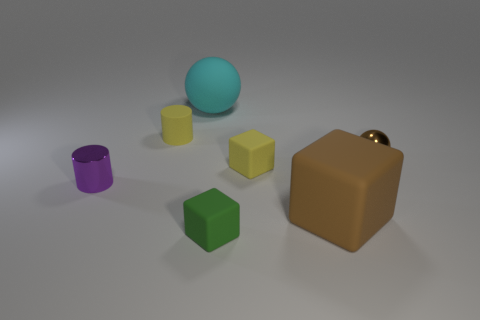There is a brown metal object; is it the same size as the yellow object on the left side of the big rubber sphere?
Your answer should be compact. Yes. What number of other objects are there of the same material as the purple object?
Give a very brief answer. 1. What number of things are either objects in front of the brown metallic object or large cyan matte objects that are left of the brown matte block?
Your answer should be very brief. 5. What is the material of the tiny brown thing that is the same shape as the cyan object?
Give a very brief answer. Metal. Is there a small cyan matte cylinder?
Offer a terse response. No. There is a block that is right of the tiny green rubber object and on the left side of the large brown cube; what is its size?
Ensure brevity in your answer.  Small. There is a small brown object; what shape is it?
Ensure brevity in your answer.  Sphere. There is a big thing that is in front of the purple metallic cylinder; are there any large brown rubber blocks right of it?
Offer a very short reply. No. What material is the yellow cylinder that is the same size as the metallic ball?
Offer a terse response. Rubber. Is there a purple thing that has the same size as the shiny sphere?
Your response must be concise. Yes. 